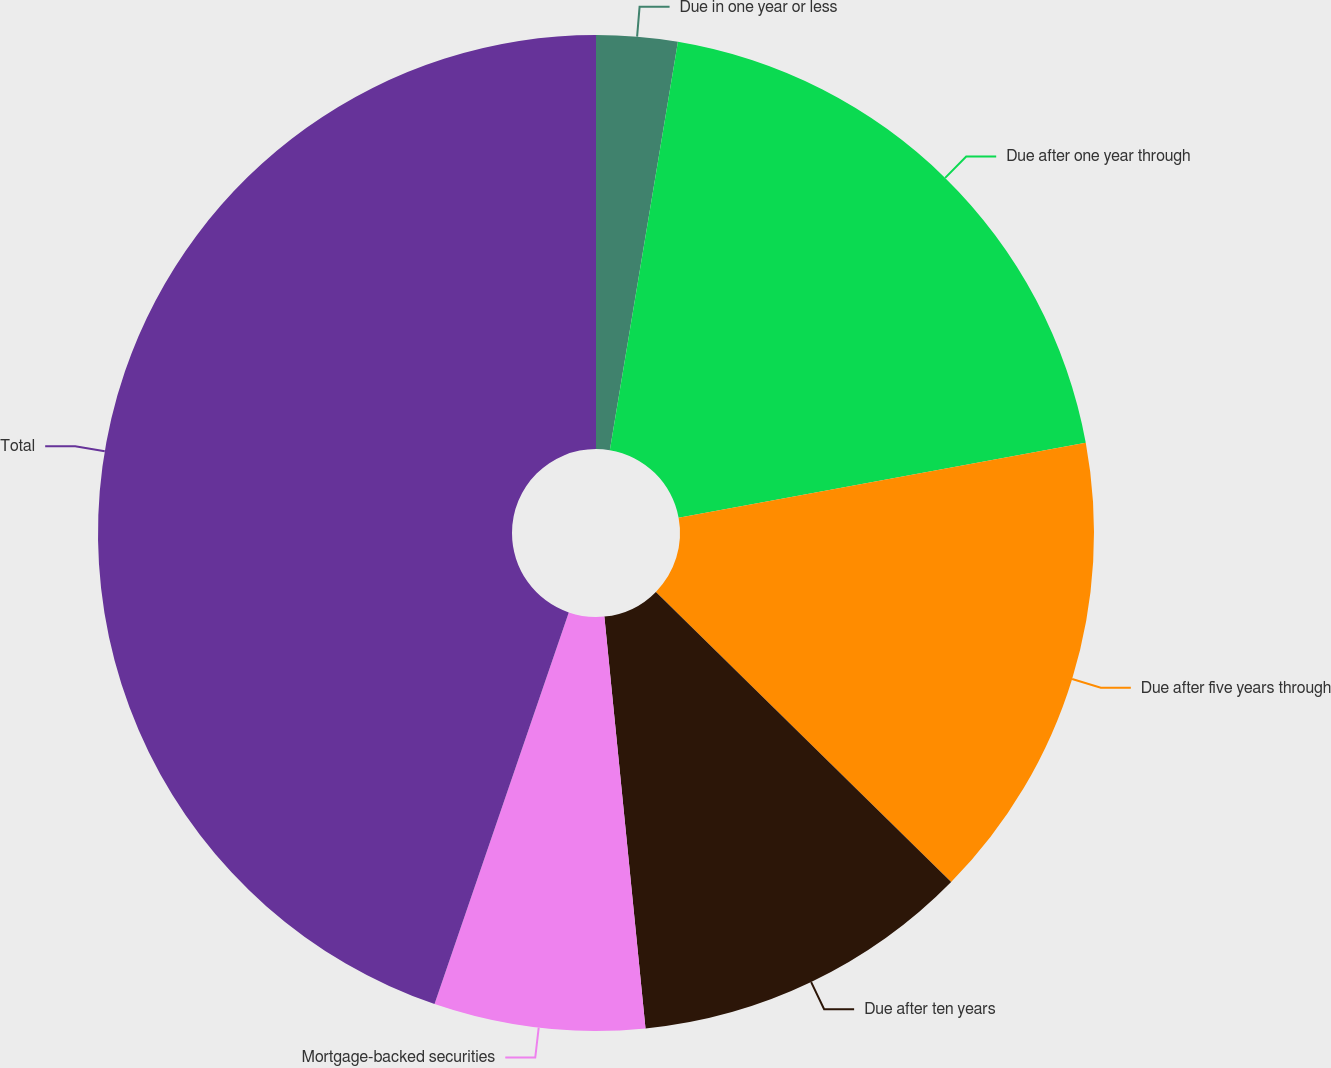Convert chart to OTSL. <chart><loc_0><loc_0><loc_500><loc_500><pie_chart><fcel>Due in one year or less<fcel>Due after one year through<fcel>Due after five years through<fcel>Due after ten years<fcel>Mortgage-backed securities<fcel>Total<nl><fcel>2.63%<fcel>19.47%<fcel>15.26%<fcel>11.05%<fcel>6.84%<fcel>44.74%<nl></chart> 